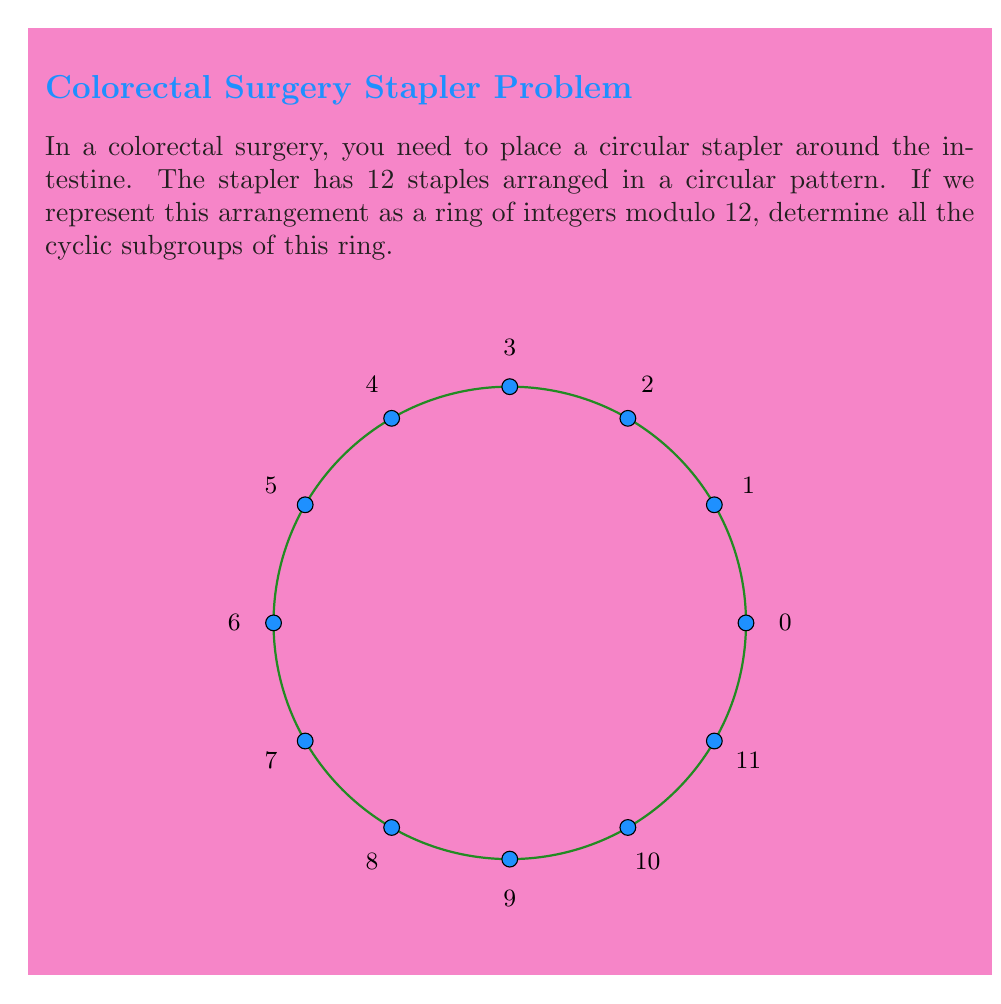Give your solution to this math problem. To determine the cyclic subgroups of the ring $\mathbb{Z}_{12}$, we need to follow these steps:

1) First, recall that in $\mathbb{Z}_{12}$, addition is performed modulo 12.

2) A cyclic subgroup is generated by a single element. For each element $a \in \mathbb{Z}_{12}$, we need to find $\langle a \rangle = \{ka \mod 12 : k \in \mathbb{Z}\}$.

3) Let's generate the cyclic subgroups for each element:

   $\langle 0 \rangle = \{0\}$
   $\langle 1 \rangle = \{0, 1, 2, 3, 4, 5, 6, 7, 8, 9, 10, 11\}$
   $\langle 2 \rangle = \{0, 2, 4, 6, 8, 10\}$
   $\langle 3 \rangle = \{0, 3, 6, 9\}$
   $\langle 4 \rangle = \{0, 4, 8\}$
   $\langle 5 \rangle = \{0, 5, 10, 3, 8, 1, 6, 11, 4, 9, 2, 7\}$
   $\langle 6 \rangle = \{0, 6\}$
   $\langle 7 \rangle = \{0, 7, 2, 9, 4, 11, 6, 1, 8, 3, 10, 5\}$
   $\langle 8 \rangle = \{0, 8, 4\}$
   $\langle 9 \rangle = \{0, 9, 6, 3\}$
   $\langle 10 \rangle = \{0, 10, 8, 6, 4, 2\}$
   $\langle 11 \rangle = \{0, 11, 10, 9, 8, 7, 6, 5, 4, 3, 2, 1\}$

4) We can see that some of these subgroups are identical. The unique cyclic subgroups are:

   $\{0\}$, $\{0, 6\}$, $\{0, 4, 8\}$, $\{0, 3, 6, 9\}$, $\{0, 2, 4, 6, 8, 10\}$, $\{0, 1, 2, 3, 4, 5, 6, 7, 8, 9, 10, 11\}$

These correspond to the subgroups generated by 0, 6, 4, 3, 2, and 1 respectively.
Answer: $\{\{0\}, \{0, 6\}, \{0, 4, 8\}, \{0, 3, 6, 9\}, \{0, 2, 4, 6, 8, 10\}, \{0, 1, 2, 3, 4, 5, 6, 7, 8, 9, 10, 11\}\}$ 